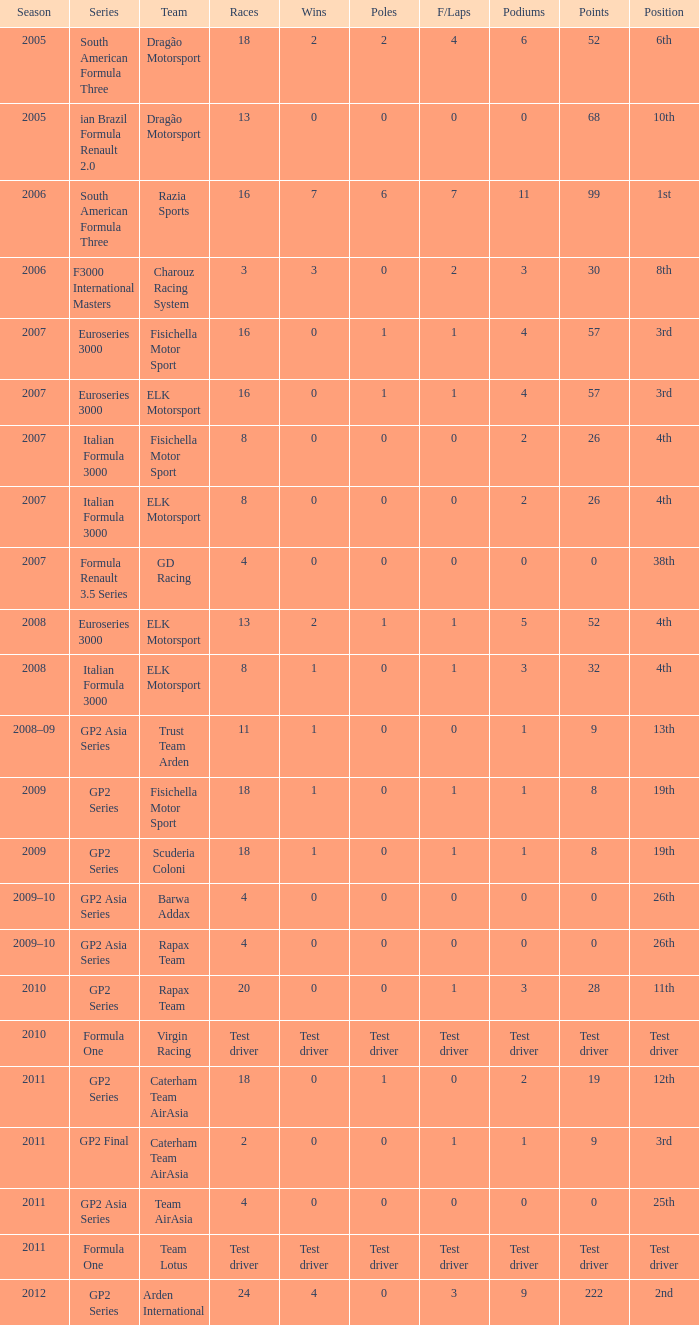What was his position in 2009 with 1 win? 19th, 19th. 